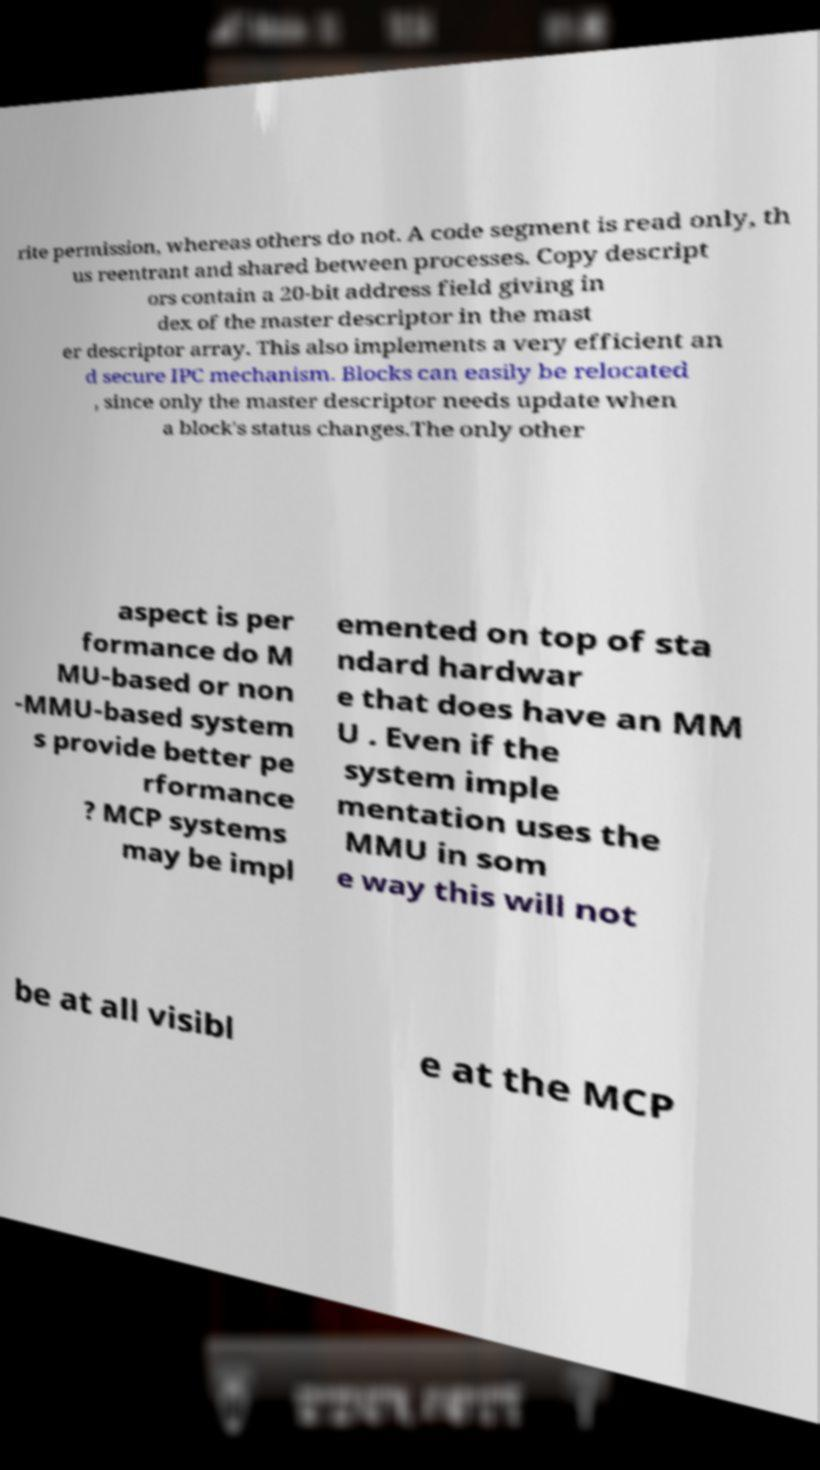Please identify and transcribe the text found in this image. rite permission, whereas others do not. A code segment is read only, th us reentrant and shared between processes. Copy descript ors contain a 20-bit address field giving in dex of the master descriptor in the mast er descriptor array. This also implements a very efficient an d secure IPC mechanism. Blocks can easily be relocated , since only the master descriptor needs update when a block's status changes.The only other aspect is per formance do M MU-based or non -MMU-based system s provide better pe rformance ? MCP systems may be impl emented on top of sta ndard hardwar e that does have an MM U . Even if the system imple mentation uses the MMU in som e way this will not be at all visibl e at the MCP 